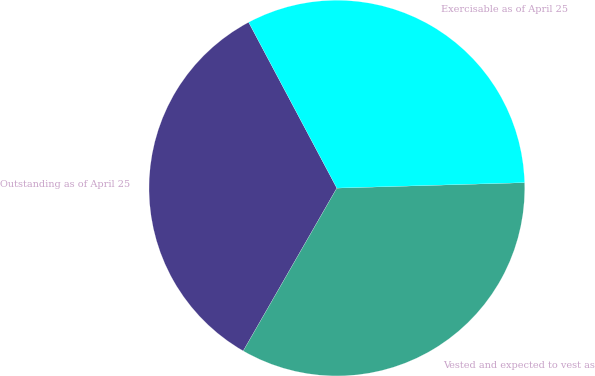<chart> <loc_0><loc_0><loc_500><loc_500><pie_chart><fcel>Outstanding as of April 25<fcel>Vested and expected to vest as<fcel>Exercisable as of April 25<nl><fcel>33.92%<fcel>33.77%<fcel>32.32%<nl></chart> 